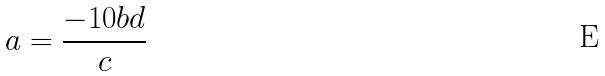Convert formula to latex. <formula><loc_0><loc_0><loc_500><loc_500>a = \frac { - 1 0 b d } { c }</formula> 